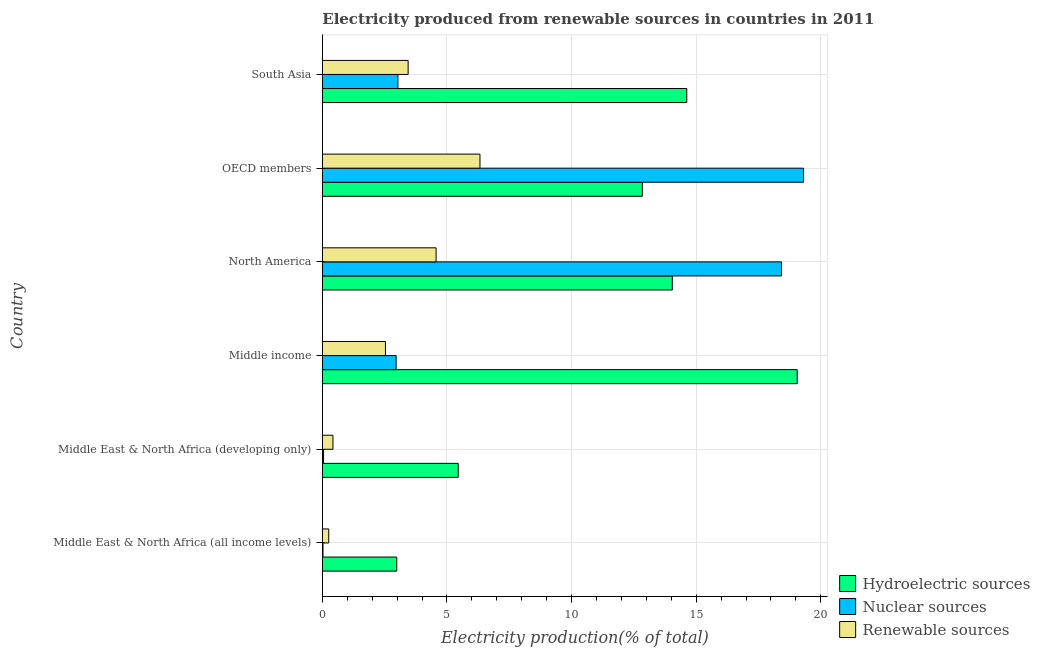How many groups of bars are there?
Make the answer very short. 6. Are the number of bars per tick equal to the number of legend labels?
Ensure brevity in your answer.  Yes. How many bars are there on the 6th tick from the top?
Provide a succinct answer. 3. What is the percentage of electricity produced by renewable sources in Middle East & North Africa (developing only)?
Keep it short and to the point. 0.43. Across all countries, what is the maximum percentage of electricity produced by renewable sources?
Ensure brevity in your answer.  6.33. Across all countries, what is the minimum percentage of electricity produced by renewable sources?
Your answer should be very brief. 0.26. In which country was the percentage of electricity produced by renewable sources minimum?
Offer a very short reply. Middle East & North Africa (all income levels). What is the total percentage of electricity produced by nuclear sources in the graph?
Your answer should be very brief. 43.8. What is the difference between the percentage of electricity produced by hydroelectric sources in Middle income and that in OECD members?
Offer a very short reply. 6.21. What is the difference between the percentage of electricity produced by hydroelectric sources in Middle income and the percentage of electricity produced by nuclear sources in OECD members?
Provide a succinct answer. -0.26. What is the difference between the percentage of electricity produced by hydroelectric sources and percentage of electricity produced by renewable sources in Middle East & North Africa (developing only)?
Make the answer very short. 5.03. In how many countries, is the percentage of electricity produced by renewable sources greater than 1 %?
Ensure brevity in your answer.  4. What is the ratio of the percentage of electricity produced by nuclear sources in Middle East & North Africa (all income levels) to that in Middle income?
Your answer should be compact. 0.01. What is the difference between the highest and the second highest percentage of electricity produced by renewable sources?
Offer a very short reply. 1.76. What is the difference between the highest and the lowest percentage of electricity produced by hydroelectric sources?
Offer a terse response. 16.07. What does the 1st bar from the top in Middle East & North Africa (all income levels) represents?
Your response must be concise. Renewable sources. What does the 3rd bar from the bottom in Middle East & North Africa (developing only) represents?
Your answer should be compact. Renewable sources. Is it the case that in every country, the sum of the percentage of electricity produced by hydroelectric sources and percentage of electricity produced by nuclear sources is greater than the percentage of electricity produced by renewable sources?
Offer a very short reply. Yes. What is the difference between two consecutive major ticks on the X-axis?
Ensure brevity in your answer.  5. Are the values on the major ticks of X-axis written in scientific E-notation?
Give a very brief answer. No. Where does the legend appear in the graph?
Give a very brief answer. Bottom right. What is the title of the graph?
Give a very brief answer. Electricity produced from renewable sources in countries in 2011. What is the label or title of the X-axis?
Keep it short and to the point. Electricity production(% of total). What is the label or title of the Y-axis?
Provide a short and direct response. Country. What is the Electricity production(% of total) in Hydroelectric sources in Middle East & North Africa (all income levels)?
Keep it short and to the point. 2.99. What is the Electricity production(% of total) in Nuclear sources in Middle East & North Africa (all income levels)?
Make the answer very short. 0.03. What is the Electricity production(% of total) in Renewable sources in Middle East & North Africa (all income levels)?
Offer a very short reply. 0.26. What is the Electricity production(% of total) of Hydroelectric sources in Middle East & North Africa (developing only)?
Your response must be concise. 5.45. What is the Electricity production(% of total) in Nuclear sources in Middle East & North Africa (developing only)?
Provide a succinct answer. 0.05. What is the Electricity production(% of total) of Renewable sources in Middle East & North Africa (developing only)?
Ensure brevity in your answer.  0.43. What is the Electricity production(% of total) of Hydroelectric sources in Middle income?
Ensure brevity in your answer.  19.05. What is the Electricity production(% of total) of Nuclear sources in Middle income?
Keep it short and to the point. 2.96. What is the Electricity production(% of total) of Renewable sources in Middle income?
Your answer should be compact. 2.53. What is the Electricity production(% of total) of Hydroelectric sources in North America?
Your response must be concise. 14.04. What is the Electricity production(% of total) of Nuclear sources in North America?
Keep it short and to the point. 18.42. What is the Electricity production(% of total) of Renewable sources in North America?
Offer a very short reply. 4.56. What is the Electricity production(% of total) in Hydroelectric sources in OECD members?
Provide a succinct answer. 12.84. What is the Electricity production(% of total) in Nuclear sources in OECD members?
Offer a terse response. 19.31. What is the Electricity production(% of total) in Renewable sources in OECD members?
Offer a very short reply. 6.33. What is the Electricity production(% of total) of Hydroelectric sources in South Asia?
Give a very brief answer. 14.62. What is the Electricity production(% of total) of Nuclear sources in South Asia?
Keep it short and to the point. 3.03. What is the Electricity production(% of total) of Renewable sources in South Asia?
Provide a short and direct response. 3.44. Across all countries, what is the maximum Electricity production(% of total) of Hydroelectric sources?
Offer a very short reply. 19.05. Across all countries, what is the maximum Electricity production(% of total) of Nuclear sources?
Provide a short and direct response. 19.31. Across all countries, what is the maximum Electricity production(% of total) of Renewable sources?
Your answer should be very brief. 6.33. Across all countries, what is the minimum Electricity production(% of total) of Hydroelectric sources?
Your response must be concise. 2.99. Across all countries, what is the minimum Electricity production(% of total) in Nuclear sources?
Your answer should be very brief. 0.03. Across all countries, what is the minimum Electricity production(% of total) of Renewable sources?
Keep it short and to the point. 0.26. What is the total Electricity production(% of total) in Hydroelectric sources in the graph?
Ensure brevity in your answer.  69. What is the total Electricity production(% of total) of Nuclear sources in the graph?
Keep it short and to the point. 43.8. What is the total Electricity production(% of total) in Renewable sources in the graph?
Give a very brief answer. 17.55. What is the difference between the Electricity production(% of total) in Hydroelectric sources in Middle East & North Africa (all income levels) and that in Middle East & North Africa (developing only)?
Provide a short and direct response. -2.47. What is the difference between the Electricity production(% of total) of Nuclear sources in Middle East & North Africa (all income levels) and that in Middle East & North Africa (developing only)?
Ensure brevity in your answer.  -0.02. What is the difference between the Electricity production(% of total) in Renewable sources in Middle East & North Africa (all income levels) and that in Middle East & North Africa (developing only)?
Provide a succinct answer. -0.17. What is the difference between the Electricity production(% of total) of Hydroelectric sources in Middle East & North Africa (all income levels) and that in Middle income?
Your response must be concise. -16.07. What is the difference between the Electricity production(% of total) in Nuclear sources in Middle East & North Africa (all income levels) and that in Middle income?
Offer a very short reply. -2.93. What is the difference between the Electricity production(% of total) of Renewable sources in Middle East & North Africa (all income levels) and that in Middle income?
Your answer should be compact. -2.28. What is the difference between the Electricity production(% of total) in Hydroelectric sources in Middle East & North Africa (all income levels) and that in North America?
Keep it short and to the point. -11.06. What is the difference between the Electricity production(% of total) in Nuclear sources in Middle East & North Africa (all income levels) and that in North America?
Your answer should be compact. -18.4. What is the difference between the Electricity production(% of total) in Renewable sources in Middle East & North Africa (all income levels) and that in North America?
Provide a short and direct response. -4.31. What is the difference between the Electricity production(% of total) in Hydroelectric sources in Middle East & North Africa (all income levels) and that in OECD members?
Your answer should be very brief. -9.85. What is the difference between the Electricity production(% of total) in Nuclear sources in Middle East & North Africa (all income levels) and that in OECD members?
Provide a succinct answer. -19.28. What is the difference between the Electricity production(% of total) in Renewable sources in Middle East & North Africa (all income levels) and that in OECD members?
Provide a succinct answer. -6.07. What is the difference between the Electricity production(% of total) in Hydroelectric sources in Middle East & North Africa (all income levels) and that in South Asia?
Keep it short and to the point. -11.64. What is the difference between the Electricity production(% of total) of Nuclear sources in Middle East & North Africa (all income levels) and that in South Asia?
Your response must be concise. -3.01. What is the difference between the Electricity production(% of total) in Renewable sources in Middle East & North Africa (all income levels) and that in South Asia?
Your answer should be very brief. -3.19. What is the difference between the Electricity production(% of total) in Hydroelectric sources in Middle East & North Africa (developing only) and that in Middle income?
Provide a succinct answer. -13.6. What is the difference between the Electricity production(% of total) of Nuclear sources in Middle East & North Africa (developing only) and that in Middle income?
Offer a very short reply. -2.91. What is the difference between the Electricity production(% of total) of Renewable sources in Middle East & North Africa (developing only) and that in Middle income?
Ensure brevity in your answer.  -2.11. What is the difference between the Electricity production(% of total) in Hydroelectric sources in Middle East & North Africa (developing only) and that in North America?
Offer a terse response. -8.59. What is the difference between the Electricity production(% of total) in Nuclear sources in Middle East & North Africa (developing only) and that in North America?
Your answer should be very brief. -18.37. What is the difference between the Electricity production(% of total) of Renewable sources in Middle East & North Africa (developing only) and that in North America?
Keep it short and to the point. -4.14. What is the difference between the Electricity production(% of total) in Hydroelectric sources in Middle East & North Africa (developing only) and that in OECD members?
Your answer should be compact. -7.39. What is the difference between the Electricity production(% of total) of Nuclear sources in Middle East & North Africa (developing only) and that in OECD members?
Your answer should be compact. -19.26. What is the difference between the Electricity production(% of total) in Renewable sources in Middle East & North Africa (developing only) and that in OECD members?
Provide a short and direct response. -5.9. What is the difference between the Electricity production(% of total) of Hydroelectric sources in Middle East & North Africa (developing only) and that in South Asia?
Make the answer very short. -9.17. What is the difference between the Electricity production(% of total) of Nuclear sources in Middle East & North Africa (developing only) and that in South Asia?
Your answer should be compact. -2.98. What is the difference between the Electricity production(% of total) in Renewable sources in Middle East & North Africa (developing only) and that in South Asia?
Provide a succinct answer. -3.02. What is the difference between the Electricity production(% of total) in Hydroelectric sources in Middle income and that in North America?
Your answer should be very brief. 5.01. What is the difference between the Electricity production(% of total) in Nuclear sources in Middle income and that in North America?
Give a very brief answer. -15.46. What is the difference between the Electricity production(% of total) of Renewable sources in Middle income and that in North America?
Provide a succinct answer. -2.03. What is the difference between the Electricity production(% of total) of Hydroelectric sources in Middle income and that in OECD members?
Your response must be concise. 6.21. What is the difference between the Electricity production(% of total) of Nuclear sources in Middle income and that in OECD members?
Provide a succinct answer. -16.35. What is the difference between the Electricity production(% of total) in Renewable sources in Middle income and that in OECD members?
Offer a very short reply. -3.79. What is the difference between the Electricity production(% of total) in Hydroelectric sources in Middle income and that in South Asia?
Offer a terse response. 4.43. What is the difference between the Electricity production(% of total) in Nuclear sources in Middle income and that in South Asia?
Keep it short and to the point. -0.07. What is the difference between the Electricity production(% of total) of Renewable sources in Middle income and that in South Asia?
Offer a very short reply. -0.91. What is the difference between the Electricity production(% of total) of Hydroelectric sources in North America and that in OECD members?
Your answer should be compact. 1.2. What is the difference between the Electricity production(% of total) in Nuclear sources in North America and that in OECD members?
Provide a short and direct response. -0.89. What is the difference between the Electricity production(% of total) in Renewable sources in North America and that in OECD members?
Your answer should be very brief. -1.76. What is the difference between the Electricity production(% of total) of Hydroelectric sources in North America and that in South Asia?
Your answer should be very brief. -0.58. What is the difference between the Electricity production(% of total) in Nuclear sources in North America and that in South Asia?
Your response must be concise. 15.39. What is the difference between the Electricity production(% of total) of Renewable sources in North America and that in South Asia?
Your answer should be very brief. 1.12. What is the difference between the Electricity production(% of total) in Hydroelectric sources in OECD members and that in South Asia?
Give a very brief answer. -1.78. What is the difference between the Electricity production(% of total) of Nuclear sources in OECD members and that in South Asia?
Ensure brevity in your answer.  16.28. What is the difference between the Electricity production(% of total) in Renewable sources in OECD members and that in South Asia?
Provide a short and direct response. 2.88. What is the difference between the Electricity production(% of total) of Hydroelectric sources in Middle East & North Africa (all income levels) and the Electricity production(% of total) of Nuclear sources in Middle East & North Africa (developing only)?
Offer a very short reply. 2.94. What is the difference between the Electricity production(% of total) in Hydroelectric sources in Middle East & North Africa (all income levels) and the Electricity production(% of total) in Renewable sources in Middle East & North Africa (developing only)?
Your answer should be compact. 2.56. What is the difference between the Electricity production(% of total) of Nuclear sources in Middle East & North Africa (all income levels) and the Electricity production(% of total) of Renewable sources in Middle East & North Africa (developing only)?
Your response must be concise. -0.4. What is the difference between the Electricity production(% of total) of Hydroelectric sources in Middle East & North Africa (all income levels) and the Electricity production(% of total) of Nuclear sources in Middle income?
Offer a very short reply. 0.03. What is the difference between the Electricity production(% of total) of Hydroelectric sources in Middle East & North Africa (all income levels) and the Electricity production(% of total) of Renewable sources in Middle income?
Keep it short and to the point. 0.45. What is the difference between the Electricity production(% of total) in Nuclear sources in Middle East & North Africa (all income levels) and the Electricity production(% of total) in Renewable sources in Middle income?
Provide a short and direct response. -2.51. What is the difference between the Electricity production(% of total) of Hydroelectric sources in Middle East & North Africa (all income levels) and the Electricity production(% of total) of Nuclear sources in North America?
Your answer should be very brief. -15.44. What is the difference between the Electricity production(% of total) in Hydroelectric sources in Middle East & North Africa (all income levels) and the Electricity production(% of total) in Renewable sources in North America?
Your answer should be compact. -1.58. What is the difference between the Electricity production(% of total) of Nuclear sources in Middle East & North Africa (all income levels) and the Electricity production(% of total) of Renewable sources in North America?
Your response must be concise. -4.54. What is the difference between the Electricity production(% of total) in Hydroelectric sources in Middle East & North Africa (all income levels) and the Electricity production(% of total) in Nuclear sources in OECD members?
Keep it short and to the point. -16.32. What is the difference between the Electricity production(% of total) of Hydroelectric sources in Middle East & North Africa (all income levels) and the Electricity production(% of total) of Renewable sources in OECD members?
Provide a short and direct response. -3.34. What is the difference between the Electricity production(% of total) in Nuclear sources in Middle East & North Africa (all income levels) and the Electricity production(% of total) in Renewable sources in OECD members?
Keep it short and to the point. -6.3. What is the difference between the Electricity production(% of total) of Hydroelectric sources in Middle East & North Africa (all income levels) and the Electricity production(% of total) of Nuclear sources in South Asia?
Your answer should be compact. -0.05. What is the difference between the Electricity production(% of total) in Hydroelectric sources in Middle East & North Africa (all income levels) and the Electricity production(% of total) in Renewable sources in South Asia?
Offer a very short reply. -0.46. What is the difference between the Electricity production(% of total) of Nuclear sources in Middle East & North Africa (all income levels) and the Electricity production(% of total) of Renewable sources in South Asia?
Offer a terse response. -3.42. What is the difference between the Electricity production(% of total) of Hydroelectric sources in Middle East & North Africa (developing only) and the Electricity production(% of total) of Nuclear sources in Middle income?
Offer a very short reply. 2.49. What is the difference between the Electricity production(% of total) in Hydroelectric sources in Middle East & North Africa (developing only) and the Electricity production(% of total) in Renewable sources in Middle income?
Offer a very short reply. 2.92. What is the difference between the Electricity production(% of total) in Nuclear sources in Middle East & North Africa (developing only) and the Electricity production(% of total) in Renewable sources in Middle income?
Offer a very short reply. -2.48. What is the difference between the Electricity production(% of total) of Hydroelectric sources in Middle East & North Africa (developing only) and the Electricity production(% of total) of Nuclear sources in North America?
Keep it short and to the point. -12.97. What is the difference between the Electricity production(% of total) in Hydroelectric sources in Middle East & North Africa (developing only) and the Electricity production(% of total) in Renewable sources in North America?
Offer a very short reply. 0.89. What is the difference between the Electricity production(% of total) of Nuclear sources in Middle East & North Africa (developing only) and the Electricity production(% of total) of Renewable sources in North America?
Offer a terse response. -4.52. What is the difference between the Electricity production(% of total) of Hydroelectric sources in Middle East & North Africa (developing only) and the Electricity production(% of total) of Nuclear sources in OECD members?
Offer a very short reply. -13.86. What is the difference between the Electricity production(% of total) in Hydroelectric sources in Middle East & North Africa (developing only) and the Electricity production(% of total) in Renewable sources in OECD members?
Your response must be concise. -0.87. What is the difference between the Electricity production(% of total) of Nuclear sources in Middle East & North Africa (developing only) and the Electricity production(% of total) of Renewable sources in OECD members?
Offer a very short reply. -6.28. What is the difference between the Electricity production(% of total) in Hydroelectric sources in Middle East & North Africa (developing only) and the Electricity production(% of total) in Nuclear sources in South Asia?
Make the answer very short. 2.42. What is the difference between the Electricity production(% of total) of Hydroelectric sources in Middle East & North Africa (developing only) and the Electricity production(% of total) of Renewable sources in South Asia?
Make the answer very short. 2.01. What is the difference between the Electricity production(% of total) of Nuclear sources in Middle East & North Africa (developing only) and the Electricity production(% of total) of Renewable sources in South Asia?
Make the answer very short. -3.39. What is the difference between the Electricity production(% of total) of Hydroelectric sources in Middle income and the Electricity production(% of total) of Nuclear sources in North America?
Keep it short and to the point. 0.63. What is the difference between the Electricity production(% of total) of Hydroelectric sources in Middle income and the Electricity production(% of total) of Renewable sources in North America?
Offer a very short reply. 14.49. What is the difference between the Electricity production(% of total) of Nuclear sources in Middle income and the Electricity production(% of total) of Renewable sources in North America?
Provide a short and direct response. -1.6. What is the difference between the Electricity production(% of total) of Hydroelectric sources in Middle income and the Electricity production(% of total) of Nuclear sources in OECD members?
Ensure brevity in your answer.  -0.26. What is the difference between the Electricity production(% of total) in Hydroelectric sources in Middle income and the Electricity production(% of total) in Renewable sources in OECD members?
Provide a short and direct response. 12.73. What is the difference between the Electricity production(% of total) in Nuclear sources in Middle income and the Electricity production(% of total) in Renewable sources in OECD members?
Offer a very short reply. -3.36. What is the difference between the Electricity production(% of total) in Hydroelectric sources in Middle income and the Electricity production(% of total) in Nuclear sources in South Asia?
Provide a succinct answer. 16.02. What is the difference between the Electricity production(% of total) in Hydroelectric sources in Middle income and the Electricity production(% of total) in Renewable sources in South Asia?
Provide a succinct answer. 15.61. What is the difference between the Electricity production(% of total) of Nuclear sources in Middle income and the Electricity production(% of total) of Renewable sources in South Asia?
Make the answer very short. -0.48. What is the difference between the Electricity production(% of total) of Hydroelectric sources in North America and the Electricity production(% of total) of Nuclear sources in OECD members?
Keep it short and to the point. -5.27. What is the difference between the Electricity production(% of total) of Hydroelectric sources in North America and the Electricity production(% of total) of Renewable sources in OECD members?
Give a very brief answer. 7.72. What is the difference between the Electricity production(% of total) of Nuclear sources in North America and the Electricity production(% of total) of Renewable sources in OECD members?
Your answer should be very brief. 12.1. What is the difference between the Electricity production(% of total) of Hydroelectric sources in North America and the Electricity production(% of total) of Nuclear sources in South Asia?
Your answer should be very brief. 11.01. What is the difference between the Electricity production(% of total) in Hydroelectric sources in North America and the Electricity production(% of total) in Renewable sources in South Asia?
Ensure brevity in your answer.  10.6. What is the difference between the Electricity production(% of total) of Nuclear sources in North America and the Electricity production(% of total) of Renewable sources in South Asia?
Ensure brevity in your answer.  14.98. What is the difference between the Electricity production(% of total) of Hydroelectric sources in OECD members and the Electricity production(% of total) of Nuclear sources in South Asia?
Your answer should be very brief. 9.81. What is the difference between the Electricity production(% of total) of Hydroelectric sources in OECD members and the Electricity production(% of total) of Renewable sources in South Asia?
Keep it short and to the point. 9.4. What is the difference between the Electricity production(% of total) in Nuclear sources in OECD members and the Electricity production(% of total) in Renewable sources in South Asia?
Offer a very short reply. 15.87. What is the average Electricity production(% of total) in Hydroelectric sources per country?
Your response must be concise. 11.5. What is the average Electricity production(% of total) in Nuclear sources per country?
Keep it short and to the point. 7.3. What is the average Electricity production(% of total) in Renewable sources per country?
Your answer should be very brief. 2.92. What is the difference between the Electricity production(% of total) of Hydroelectric sources and Electricity production(% of total) of Nuclear sources in Middle East & North Africa (all income levels)?
Give a very brief answer. 2.96. What is the difference between the Electricity production(% of total) of Hydroelectric sources and Electricity production(% of total) of Renewable sources in Middle East & North Africa (all income levels)?
Offer a very short reply. 2.73. What is the difference between the Electricity production(% of total) of Nuclear sources and Electricity production(% of total) of Renewable sources in Middle East & North Africa (all income levels)?
Ensure brevity in your answer.  -0.23. What is the difference between the Electricity production(% of total) of Hydroelectric sources and Electricity production(% of total) of Nuclear sources in Middle East & North Africa (developing only)?
Your answer should be compact. 5.4. What is the difference between the Electricity production(% of total) of Hydroelectric sources and Electricity production(% of total) of Renewable sources in Middle East & North Africa (developing only)?
Offer a very short reply. 5.03. What is the difference between the Electricity production(% of total) in Nuclear sources and Electricity production(% of total) in Renewable sources in Middle East & North Africa (developing only)?
Provide a short and direct response. -0.38. What is the difference between the Electricity production(% of total) in Hydroelectric sources and Electricity production(% of total) in Nuclear sources in Middle income?
Offer a very short reply. 16.09. What is the difference between the Electricity production(% of total) of Hydroelectric sources and Electricity production(% of total) of Renewable sources in Middle income?
Provide a succinct answer. 16.52. What is the difference between the Electricity production(% of total) of Nuclear sources and Electricity production(% of total) of Renewable sources in Middle income?
Ensure brevity in your answer.  0.43. What is the difference between the Electricity production(% of total) of Hydroelectric sources and Electricity production(% of total) of Nuclear sources in North America?
Offer a terse response. -4.38. What is the difference between the Electricity production(% of total) of Hydroelectric sources and Electricity production(% of total) of Renewable sources in North America?
Provide a succinct answer. 9.48. What is the difference between the Electricity production(% of total) in Nuclear sources and Electricity production(% of total) in Renewable sources in North America?
Ensure brevity in your answer.  13.86. What is the difference between the Electricity production(% of total) in Hydroelectric sources and Electricity production(% of total) in Nuclear sources in OECD members?
Provide a short and direct response. -6.47. What is the difference between the Electricity production(% of total) of Hydroelectric sources and Electricity production(% of total) of Renewable sources in OECD members?
Offer a terse response. 6.51. What is the difference between the Electricity production(% of total) of Nuclear sources and Electricity production(% of total) of Renewable sources in OECD members?
Your answer should be very brief. 12.98. What is the difference between the Electricity production(% of total) in Hydroelectric sources and Electricity production(% of total) in Nuclear sources in South Asia?
Your answer should be compact. 11.59. What is the difference between the Electricity production(% of total) in Hydroelectric sources and Electricity production(% of total) in Renewable sources in South Asia?
Provide a succinct answer. 11.18. What is the difference between the Electricity production(% of total) of Nuclear sources and Electricity production(% of total) of Renewable sources in South Asia?
Your answer should be compact. -0.41. What is the ratio of the Electricity production(% of total) of Hydroelectric sources in Middle East & North Africa (all income levels) to that in Middle East & North Africa (developing only)?
Ensure brevity in your answer.  0.55. What is the ratio of the Electricity production(% of total) in Nuclear sources in Middle East & North Africa (all income levels) to that in Middle East & North Africa (developing only)?
Keep it short and to the point. 0.55. What is the ratio of the Electricity production(% of total) of Renewable sources in Middle East & North Africa (all income levels) to that in Middle East & North Africa (developing only)?
Your answer should be compact. 0.6. What is the ratio of the Electricity production(% of total) of Hydroelectric sources in Middle East & North Africa (all income levels) to that in Middle income?
Your answer should be very brief. 0.16. What is the ratio of the Electricity production(% of total) in Nuclear sources in Middle East & North Africa (all income levels) to that in Middle income?
Your answer should be compact. 0.01. What is the ratio of the Electricity production(% of total) of Renewable sources in Middle East & North Africa (all income levels) to that in Middle income?
Give a very brief answer. 0.1. What is the ratio of the Electricity production(% of total) in Hydroelectric sources in Middle East & North Africa (all income levels) to that in North America?
Your answer should be compact. 0.21. What is the ratio of the Electricity production(% of total) in Nuclear sources in Middle East & North Africa (all income levels) to that in North America?
Offer a very short reply. 0. What is the ratio of the Electricity production(% of total) in Renewable sources in Middle East & North Africa (all income levels) to that in North America?
Offer a terse response. 0.06. What is the ratio of the Electricity production(% of total) of Hydroelectric sources in Middle East & North Africa (all income levels) to that in OECD members?
Provide a succinct answer. 0.23. What is the ratio of the Electricity production(% of total) of Nuclear sources in Middle East & North Africa (all income levels) to that in OECD members?
Your answer should be compact. 0. What is the ratio of the Electricity production(% of total) in Renewable sources in Middle East & North Africa (all income levels) to that in OECD members?
Provide a short and direct response. 0.04. What is the ratio of the Electricity production(% of total) in Hydroelectric sources in Middle East & North Africa (all income levels) to that in South Asia?
Your answer should be very brief. 0.2. What is the ratio of the Electricity production(% of total) in Nuclear sources in Middle East & North Africa (all income levels) to that in South Asia?
Provide a succinct answer. 0.01. What is the ratio of the Electricity production(% of total) in Renewable sources in Middle East & North Africa (all income levels) to that in South Asia?
Your answer should be very brief. 0.07. What is the ratio of the Electricity production(% of total) of Hydroelectric sources in Middle East & North Africa (developing only) to that in Middle income?
Your answer should be very brief. 0.29. What is the ratio of the Electricity production(% of total) in Nuclear sources in Middle East & North Africa (developing only) to that in Middle income?
Your answer should be compact. 0.02. What is the ratio of the Electricity production(% of total) in Renewable sources in Middle East & North Africa (developing only) to that in Middle income?
Your answer should be very brief. 0.17. What is the ratio of the Electricity production(% of total) in Hydroelectric sources in Middle East & North Africa (developing only) to that in North America?
Offer a terse response. 0.39. What is the ratio of the Electricity production(% of total) of Nuclear sources in Middle East & North Africa (developing only) to that in North America?
Give a very brief answer. 0. What is the ratio of the Electricity production(% of total) of Renewable sources in Middle East & North Africa (developing only) to that in North America?
Provide a succinct answer. 0.09. What is the ratio of the Electricity production(% of total) of Hydroelectric sources in Middle East & North Africa (developing only) to that in OECD members?
Keep it short and to the point. 0.42. What is the ratio of the Electricity production(% of total) of Nuclear sources in Middle East & North Africa (developing only) to that in OECD members?
Keep it short and to the point. 0. What is the ratio of the Electricity production(% of total) in Renewable sources in Middle East & North Africa (developing only) to that in OECD members?
Ensure brevity in your answer.  0.07. What is the ratio of the Electricity production(% of total) of Hydroelectric sources in Middle East & North Africa (developing only) to that in South Asia?
Your answer should be compact. 0.37. What is the ratio of the Electricity production(% of total) of Nuclear sources in Middle East & North Africa (developing only) to that in South Asia?
Your response must be concise. 0.02. What is the ratio of the Electricity production(% of total) of Renewable sources in Middle East & North Africa (developing only) to that in South Asia?
Keep it short and to the point. 0.12. What is the ratio of the Electricity production(% of total) of Hydroelectric sources in Middle income to that in North America?
Offer a terse response. 1.36. What is the ratio of the Electricity production(% of total) in Nuclear sources in Middle income to that in North America?
Provide a succinct answer. 0.16. What is the ratio of the Electricity production(% of total) of Renewable sources in Middle income to that in North America?
Provide a short and direct response. 0.55. What is the ratio of the Electricity production(% of total) of Hydroelectric sources in Middle income to that in OECD members?
Keep it short and to the point. 1.48. What is the ratio of the Electricity production(% of total) of Nuclear sources in Middle income to that in OECD members?
Your answer should be compact. 0.15. What is the ratio of the Electricity production(% of total) of Renewable sources in Middle income to that in OECD members?
Ensure brevity in your answer.  0.4. What is the ratio of the Electricity production(% of total) of Hydroelectric sources in Middle income to that in South Asia?
Ensure brevity in your answer.  1.3. What is the ratio of the Electricity production(% of total) of Nuclear sources in Middle income to that in South Asia?
Your response must be concise. 0.98. What is the ratio of the Electricity production(% of total) in Renewable sources in Middle income to that in South Asia?
Give a very brief answer. 0.74. What is the ratio of the Electricity production(% of total) in Hydroelectric sources in North America to that in OECD members?
Make the answer very short. 1.09. What is the ratio of the Electricity production(% of total) in Nuclear sources in North America to that in OECD members?
Your response must be concise. 0.95. What is the ratio of the Electricity production(% of total) in Renewable sources in North America to that in OECD members?
Keep it short and to the point. 0.72. What is the ratio of the Electricity production(% of total) of Hydroelectric sources in North America to that in South Asia?
Offer a very short reply. 0.96. What is the ratio of the Electricity production(% of total) of Nuclear sources in North America to that in South Asia?
Ensure brevity in your answer.  6.08. What is the ratio of the Electricity production(% of total) of Renewable sources in North America to that in South Asia?
Make the answer very short. 1.33. What is the ratio of the Electricity production(% of total) of Hydroelectric sources in OECD members to that in South Asia?
Your answer should be very brief. 0.88. What is the ratio of the Electricity production(% of total) of Nuclear sources in OECD members to that in South Asia?
Your answer should be compact. 6.37. What is the ratio of the Electricity production(% of total) in Renewable sources in OECD members to that in South Asia?
Your answer should be very brief. 1.84. What is the difference between the highest and the second highest Electricity production(% of total) in Hydroelectric sources?
Provide a short and direct response. 4.43. What is the difference between the highest and the second highest Electricity production(% of total) of Nuclear sources?
Provide a succinct answer. 0.89. What is the difference between the highest and the second highest Electricity production(% of total) in Renewable sources?
Offer a terse response. 1.76. What is the difference between the highest and the lowest Electricity production(% of total) of Hydroelectric sources?
Ensure brevity in your answer.  16.07. What is the difference between the highest and the lowest Electricity production(% of total) in Nuclear sources?
Provide a succinct answer. 19.28. What is the difference between the highest and the lowest Electricity production(% of total) in Renewable sources?
Provide a short and direct response. 6.07. 